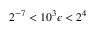Convert formula to latex. <formula><loc_0><loc_0><loc_500><loc_500>2 ^ { - 7 } < 1 0 ^ { 3 } \epsilon < 2 ^ { 4 }</formula> 